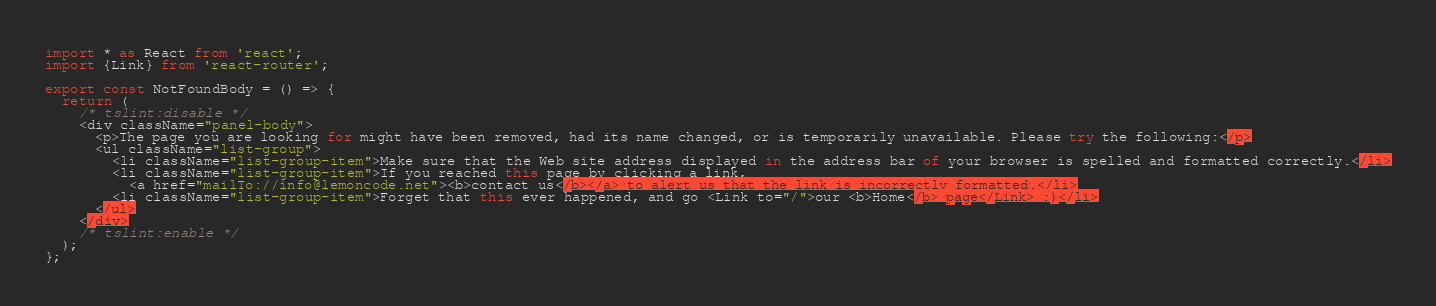Convert code to text. <code><loc_0><loc_0><loc_500><loc_500><_TypeScript_>import * as React from 'react';
import {Link} from 'react-router';

export const NotFoundBody = () => {
  return (
    /* tslint:disable */
    <div className="panel-body">
      <p>The page you are looking for might have been removed, had its name changed, or is temporarily unavailable. Please try the following:</p>
      <ul className="list-group">
        <li className="list-group-item">Make sure that the Web site address displayed in the address bar of your browser is spelled and formatted correctly.</li>
        <li className="list-group-item">If you reached this page by clicking a link,
          <a href="mailTo://info@lemoncode.net"><b>contact us</b></a> to alert us that the link is incorrectly formatted.</li>
        <li className="list-group-item">Forget that this ever happened, and go <Link to="/">our <b>Home</b> page</Link> :)</li>
      </ul>
    </div>
    /* tslint:enable */
  );
};
</code> 